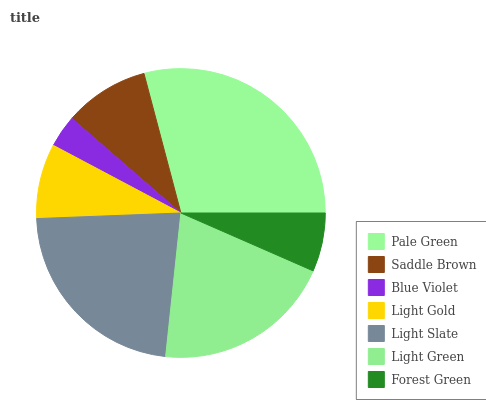Is Blue Violet the minimum?
Answer yes or no. Yes. Is Pale Green the maximum?
Answer yes or no. Yes. Is Saddle Brown the minimum?
Answer yes or no. No. Is Saddle Brown the maximum?
Answer yes or no. No. Is Pale Green greater than Saddle Brown?
Answer yes or no. Yes. Is Saddle Brown less than Pale Green?
Answer yes or no. Yes. Is Saddle Brown greater than Pale Green?
Answer yes or no. No. Is Pale Green less than Saddle Brown?
Answer yes or no. No. Is Saddle Brown the high median?
Answer yes or no. Yes. Is Saddle Brown the low median?
Answer yes or no. Yes. Is Light Green the high median?
Answer yes or no. No. Is Blue Violet the low median?
Answer yes or no. No. 